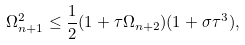Convert formula to latex. <formula><loc_0><loc_0><loc_500><loc_500>\Omega _ { n + 1 } ^ { 2 } \leq \frac { 1 } { 2 } ( 1 + \tau \Omega _ { n + 2 } ) ( 1 + \sigma \tau ^ { 3 } ) ,</formula> 